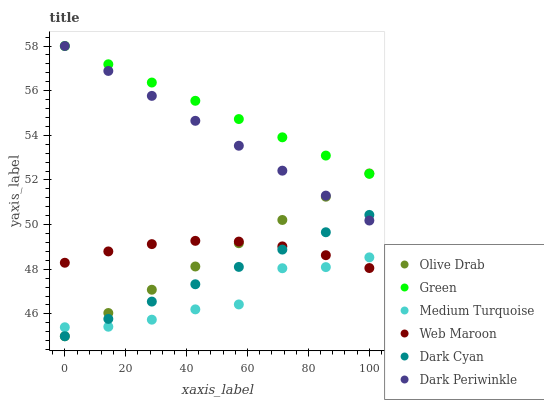Does Medium Turquoise have the minimum area under the curve?
Answer yes or no. Yes. Does Green have the maximum area under the curve?
Answer yes or no. Yes. Does Green have the minimum area under the curve?
Answer yes or no. No. Does Medium Turquoise have the maximum area under the curve?
Answer yes or no. No. Is Dark Cyan the smoothest?
Answer yes or no. Yes. Is Medium Turquoise the roughest?
Answer yes or no. Yes. Is Green the smoothest?
Answer yes or no. No. Is Green the roughest?
Answer yes or no. No. Does Dark Cyan have the lowest value?
Answer yes or no. Yes. Does Medium Turquoise have the lowest value?
Answer yes or no. No. Does Dark Periwinkle have the highest value?
Answer yes or no. Yes. Does Medium Turquoise have the highest value?
Answer yes or no. No. Is Dark Cyan less than Green?
Answer yes or no. Yes. Is Green greater than Dark Cyan?
Answer yes or no. Yes. Does Dark Cyan intersect Medium Turquoise?
Answer yes or no. Yes. Is Dark Cyan less than Medium Turquoise?
Answer yes or no. No. Is Dark Cyan greater than Medium Turquoise?
Answer yes or no. No. Does Dark Cyan intersect Green?
Answer yes or no. No. 